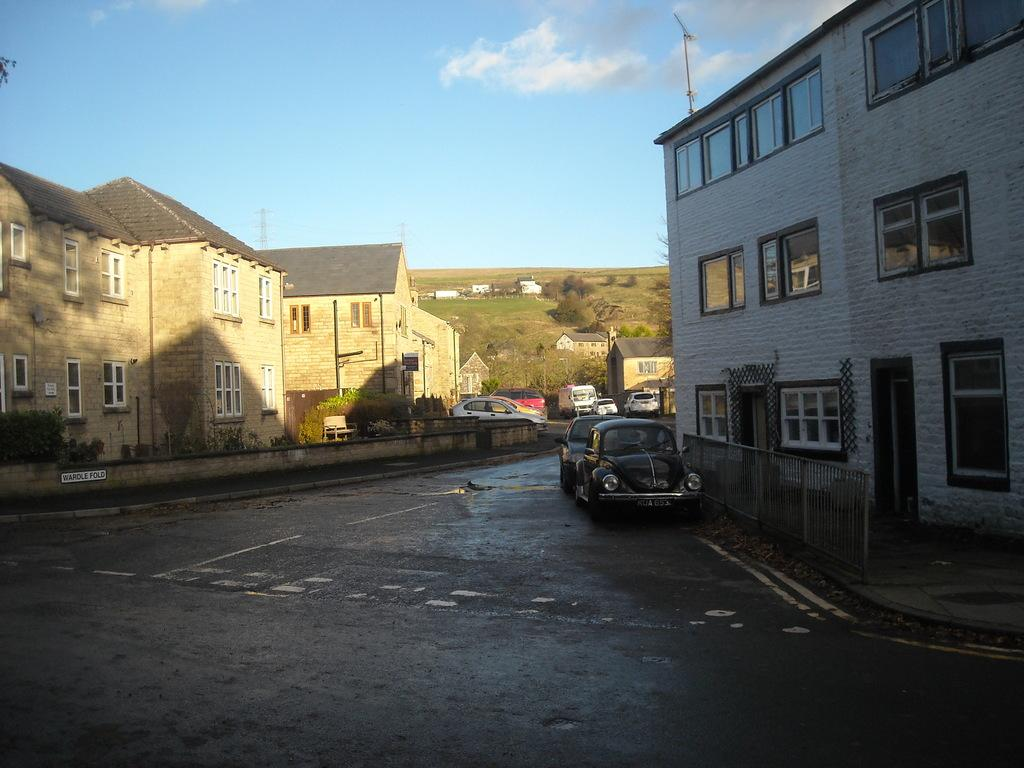What is happening on the road in the image? There are vehicles on the road in the image. What type of structures are located near the vehicles? There are houses beside the vehicles in the image. What natural elements can be seen in the image? There are trees in the image. What type of linen is draped over the vehicles in the image? There is no linen draped over the vehicles in the image; it only features vehicles, houses, and trees. What is the view from the vehicles in the image? The image does not provide a view from the vehicles, as it is a static representation of the scene. 